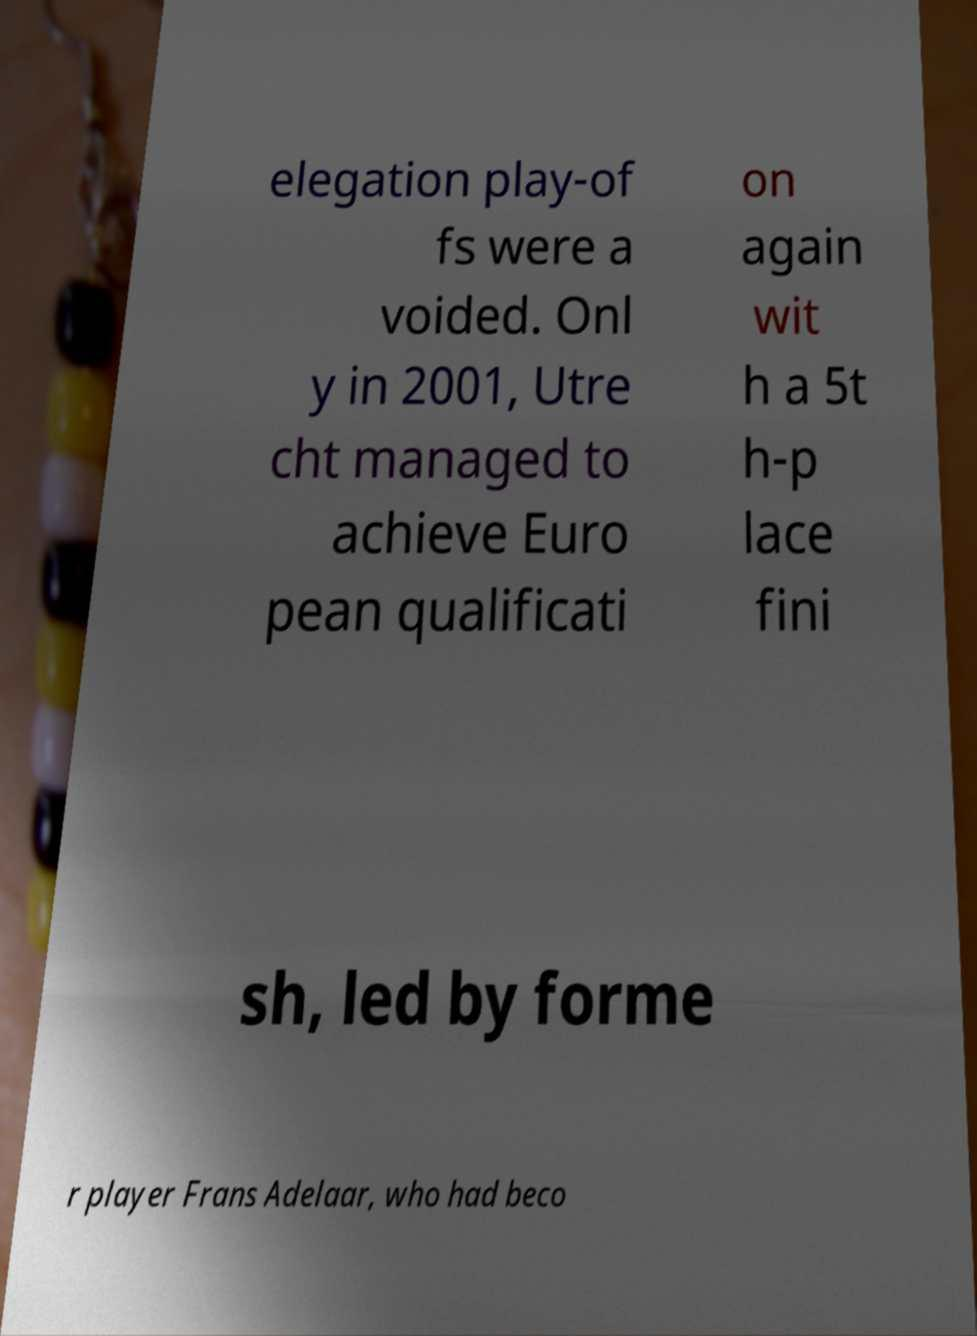For documentation purposes, I need the text within this image transcribed. Could you provide that? elegation play-of fs were a voided. Onl y in 2001, Utre cht managed to achieve Euro pean qualificati on again wit h a 5t h-p lace fini sh, led by forme r player Frans Adelaar, who had beco 